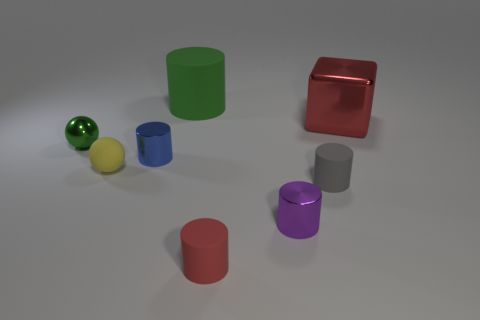Subtract all gray matte cylinders. How many cylinders are left? 4 Subtract all gray cylinders. How many cylinders are left? 4 Add 2 big yellow balls. How many objects exist? 10 Subtract 4 cylinders. How many cylinders are left? 1 Subtract all blocks. How many objects are left? 7 Subtract all cyan cylinders. Subtract all yellow balls. How many cylinders are left? 5 Subtract all cyan spheres. How many green cylinders are left? 1 Subtract all tiny brown matte spheres. Subtract all red metallic cubes. How many objects are left? 7 Add 2 green spheres. How many green spheres are left? 3 Add 3 blue things. How many blue things exist? 4 